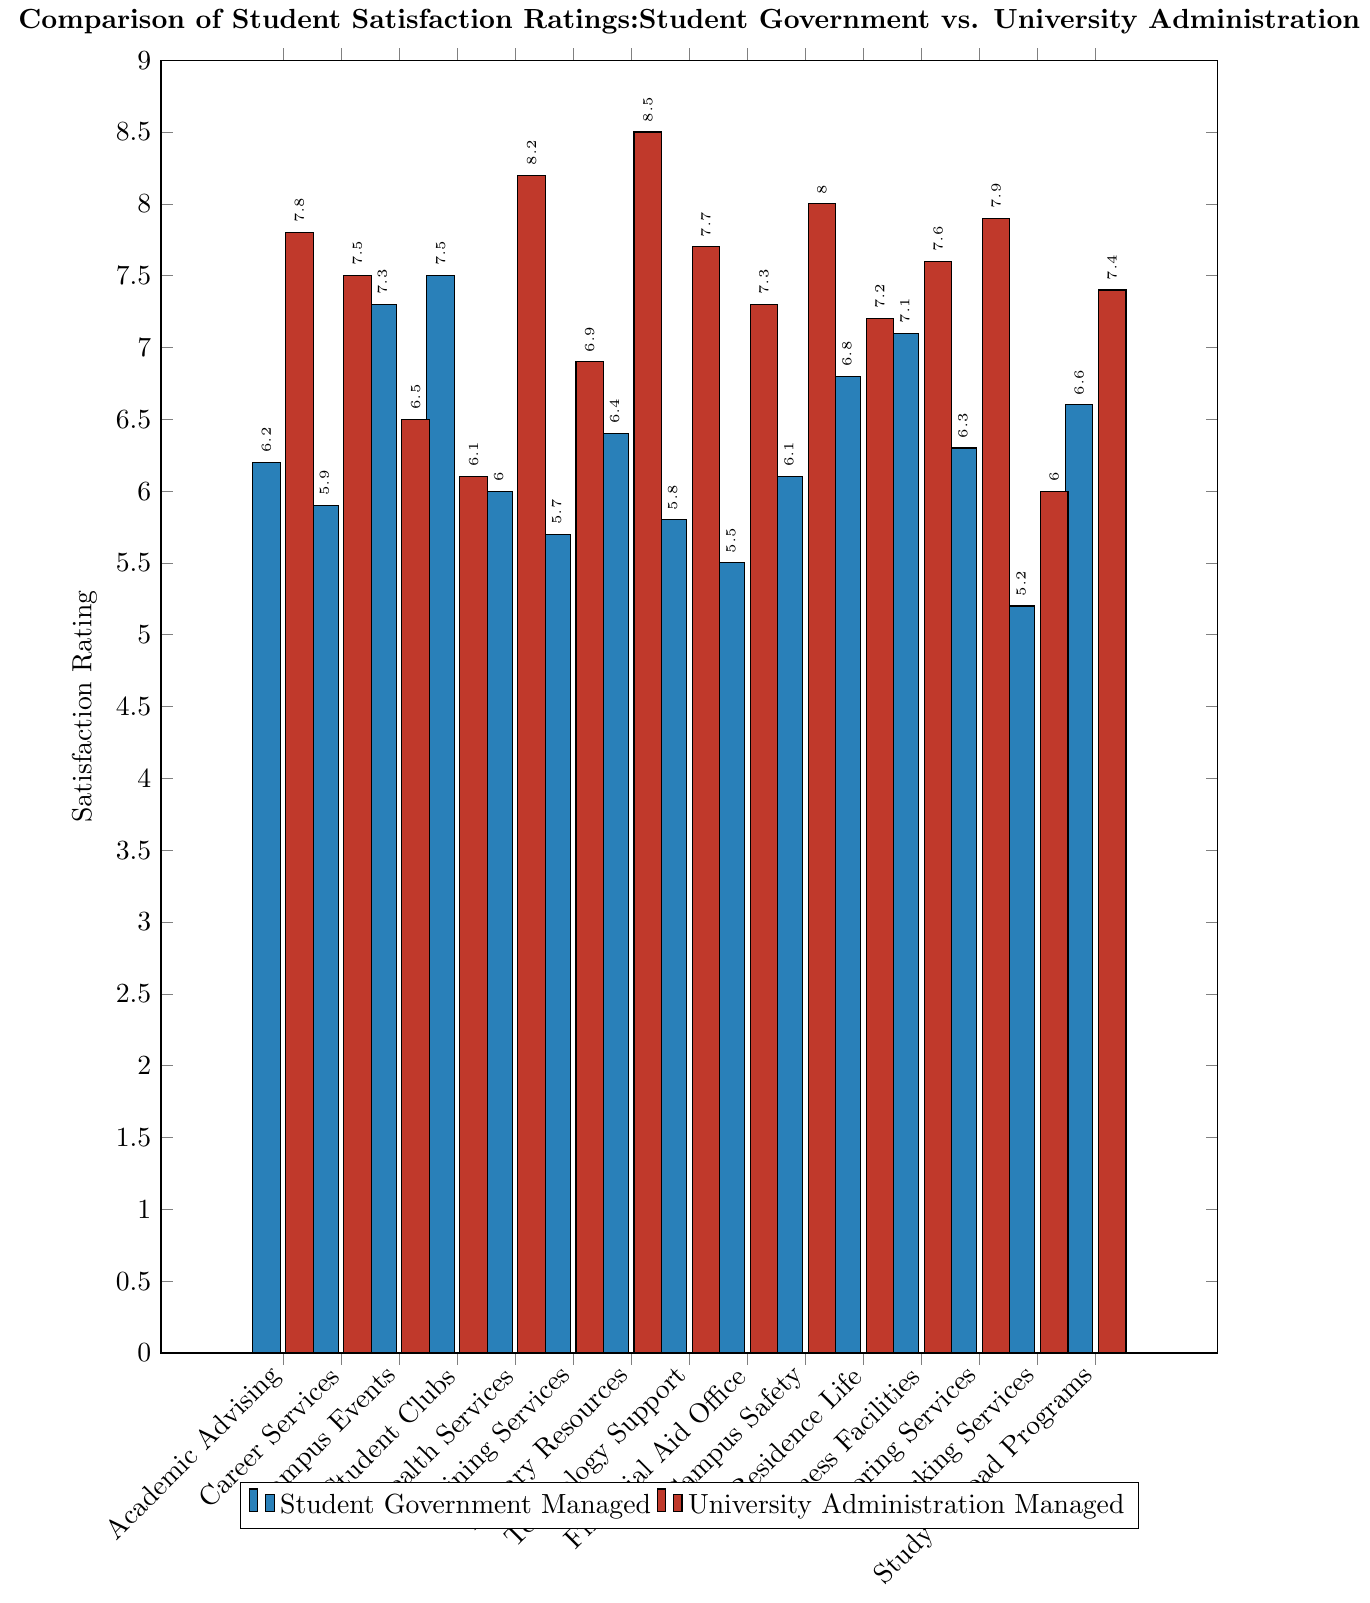Which service managed by the student government has the highest satisfaction rating? Look at the blue bars representing student government managed services and identify the tallest one. The tallest blue bar is for Student Clubs, which has a satisfaction rating of 7.5.
Answer: Student Clubs Which service managed by the university administration has the highest satisfaction rating? Look at the red bars representing university administration managed services and identify the highest one. The tallest red bar corresponds to Library Resources with a satisfaction rating of 8.5.
Answer: Library Resources What is the average satisfaction rating for Technology Support across both management types? Find the satisfaction ratings for Technology Support from both student government (5.8) and university administration (7.7). The average is calculated as (5.8 + 7.7) / 2 = 6.75.
Answer: 6.75 Which service has the largest difference in satisfaction ratings between student government and university administration? Compute the differences for each service by subtracting the student government rating from the university administration rating. Find the service with the largest absolute value of these differences. The differences are: Academic Advising (1.6), Career Services (1.6), Campus Events (-0.8), Student Clubs (-1.4), Health Services (2.2), Dining Services (1.2), Library Resources (2.1), Technology Support (1.9), Financial Aid Office (1.8), Campus Safety (1.9), Residence Life (0.4), Fitness Facilities (0.5), Tutoring Services (1.6), Parking Services (0.8), Study Abroad Programs (0.8). The largest difference is in Health Services (2.2).
Answer: Health Services Is the satisfaction rating for Campus Events higher when managed by student government or university administration? Compare the satisfaction ratings for Campus Events: student government (7.3) and university administration (6.5). The student government-managed rating is higher.
Answer: Student government What is the sum of the satisfaction ratings for Dining Services across both management types? Find the satisfaction ratings for Dining Services from both student government (5.7) and university administration (6.9). The sum is calculated as 5.7 + 6.9 = 12.6.
Answer: 12.6 Which management type has a higher overall average satisfaction rating for all services combined? Calculate the average satisfaction rating for all services for both management types. First, sum the student government ratings: 6.2 + 5.9 + 7.3 + 7.5 + 6.0 + 5.7 + 6.4 + 5.8 + 5.5 + 6.1 + 6.8 + 7.1 + 6.3 + 5.2 + 6.6 = 96.4. Then divide by the number of services: 96.4 / 15 = 6.43. Sum the university administration ratings: 7.8 + 7.5 + 6.5 + 6.1 + 8.2 + 6.9 + 8.5 + 7.7 + 7.3 + 8.0 + 7.2 + 7.6 + 7.9 + 6.0 + 7.4 = 113.6. Divide by the number of services: 113.6 / 15 = 7.57. University administration has the higher overall average.
Answer: University administration For which service is the satisfaction rating closest to 7.0 regardless of who manages it? Identify satisfaction ratings close to 7.0: Student government - Campus Events (7.3), Student Clubs (7.5), Residence Life (6.8), Fitness Facilities (7.1); University administration - Campus Events (6.5), Fitness Facilities (7.6), Study Abroad Programs (7.4). The closest rating is Residence Life (6.8).
Answer: Residence Life Which service has the same satisfaction rating trend (both ratings increasing or both decreasing) across both management types? Check each service's ratings for an increasing or decreasing trend. Similar trends: Campus Events (7.3, 6.5 - decreasing), Student Clubs (7.5, 6.1 - decreasing), Fitness Facilities (7.1, 7.6 - increasing). These show similar rating trends.
Answer: Campus Events, Student Clubs, Fitness Facilities 